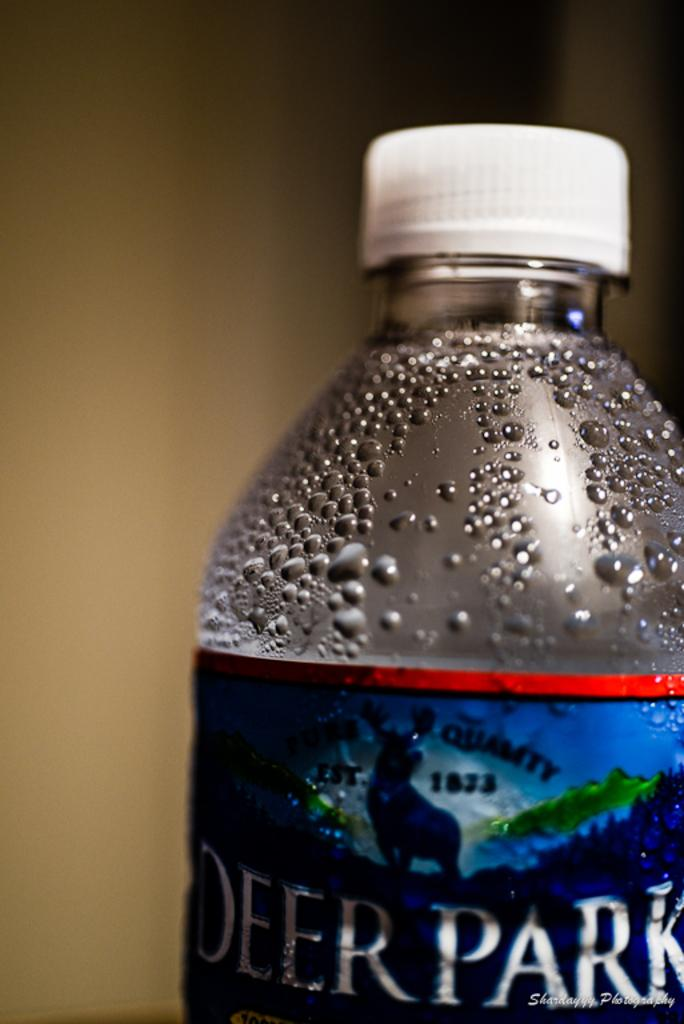<image>
Render a clear and concise summary of the photo. The bottle of Deer Park water states it was established in the 1800s. 